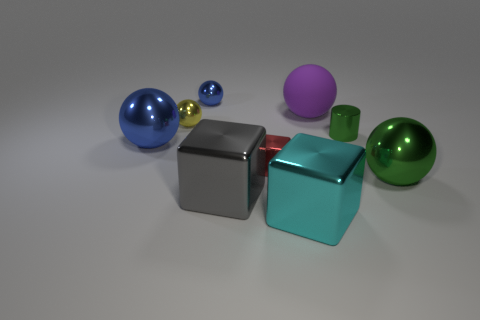Is there any other thing that is made of the same material as the large purple thing?
Keep it short and to the point. No. Are there any other things that have the same color as the tiny metallic cylinder?
Provide a short and direct response. Yes. What size is the red shiny block?
Provide a short and direct response. Small. What is the shape of the gray object that is made of the same material as the tiny green thing?
Your answer should be compact. Cube. There is a metal thing in front of the big gray block; is it the same shape as the purple rubber thing?
Give a very brief answer. No. What number of things are large blue shiny balls or small yellow shiny things?
Keep it short and to the point. 2. What is the big thing that is to the right of the small blue metal thing and left of the cyan metal block made of?
Give a very brief answer. Metal. Is the size of the purple matte object the same as the cyan metal cube?
Provide a short and direct response. Yes. What size is the metallic sphere on the right side of the big thing in front of the big gray block?
Keep it short and to the point. Large. What number of metal things are on the right side of the cyan metal thing and in front of the large green sphere?
Your answer should be compact. 0. 